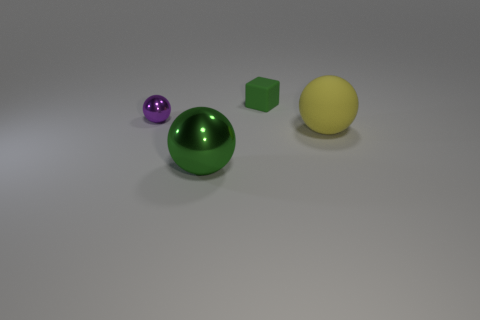Subtract all tiny balls. How many balls are left? 2 Add 1 tiny purple matte cubes. How many objects exist? 5 Subtract all purple balls. How many balls are left? 2 Subtract 0 gray cylinders. How many objects are left? 4 Subtract all cubes. How many objects are left? 3 Subtract 1 spheres. How many spheres are left? 2 Subtract all red cubes. Subtract all yellow balls. How many cubes are left? 1 Subtract all yellow cylinders. How many gray balls are left? 0 Subtract all green rubber things. Subtract all tiny green rubber objects. How many objects are left? 2 Add 4 small purple metal objects. How many small purple metal objects are left? 5 